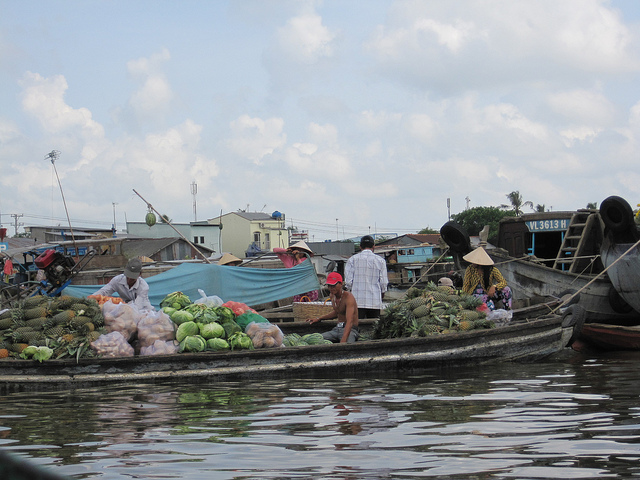Identify the text displayed in this image. VL3613H 